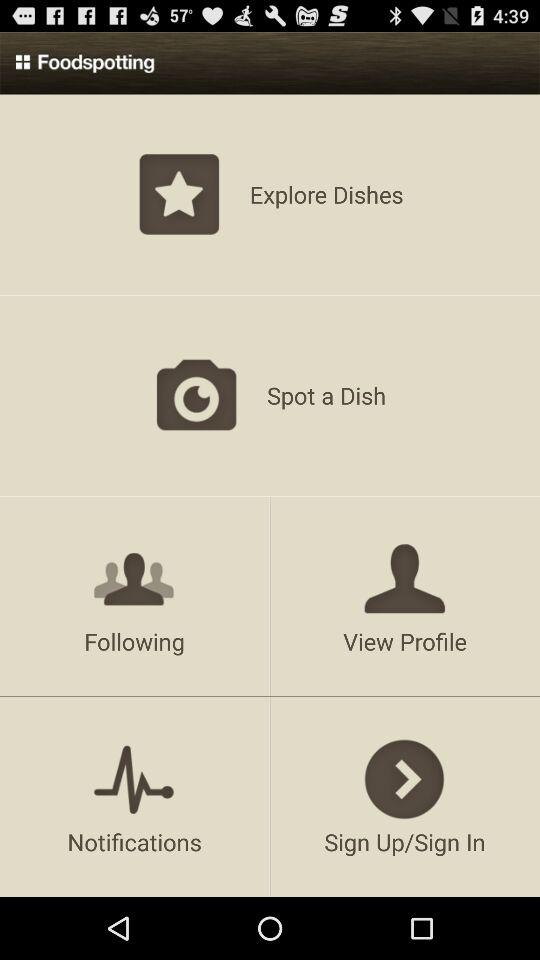What is the application name? The application name is "Foodspotting". 